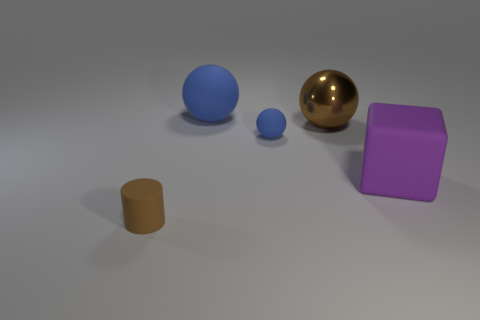Add 1 tiny purple metallic spheres. How many objects exist? 6 Subtract all spheres. How many objects are left? 2 Add 1 large metal spheres. How many large metal spheres exist? 2 Subtract 0 red spheres. How many objects are left? 5 Subtract all small matte things. Subtract all small green shiny cylinders. How many objects are left? 3 Add 4 small blue objects. How many small blue objects are left? 5 